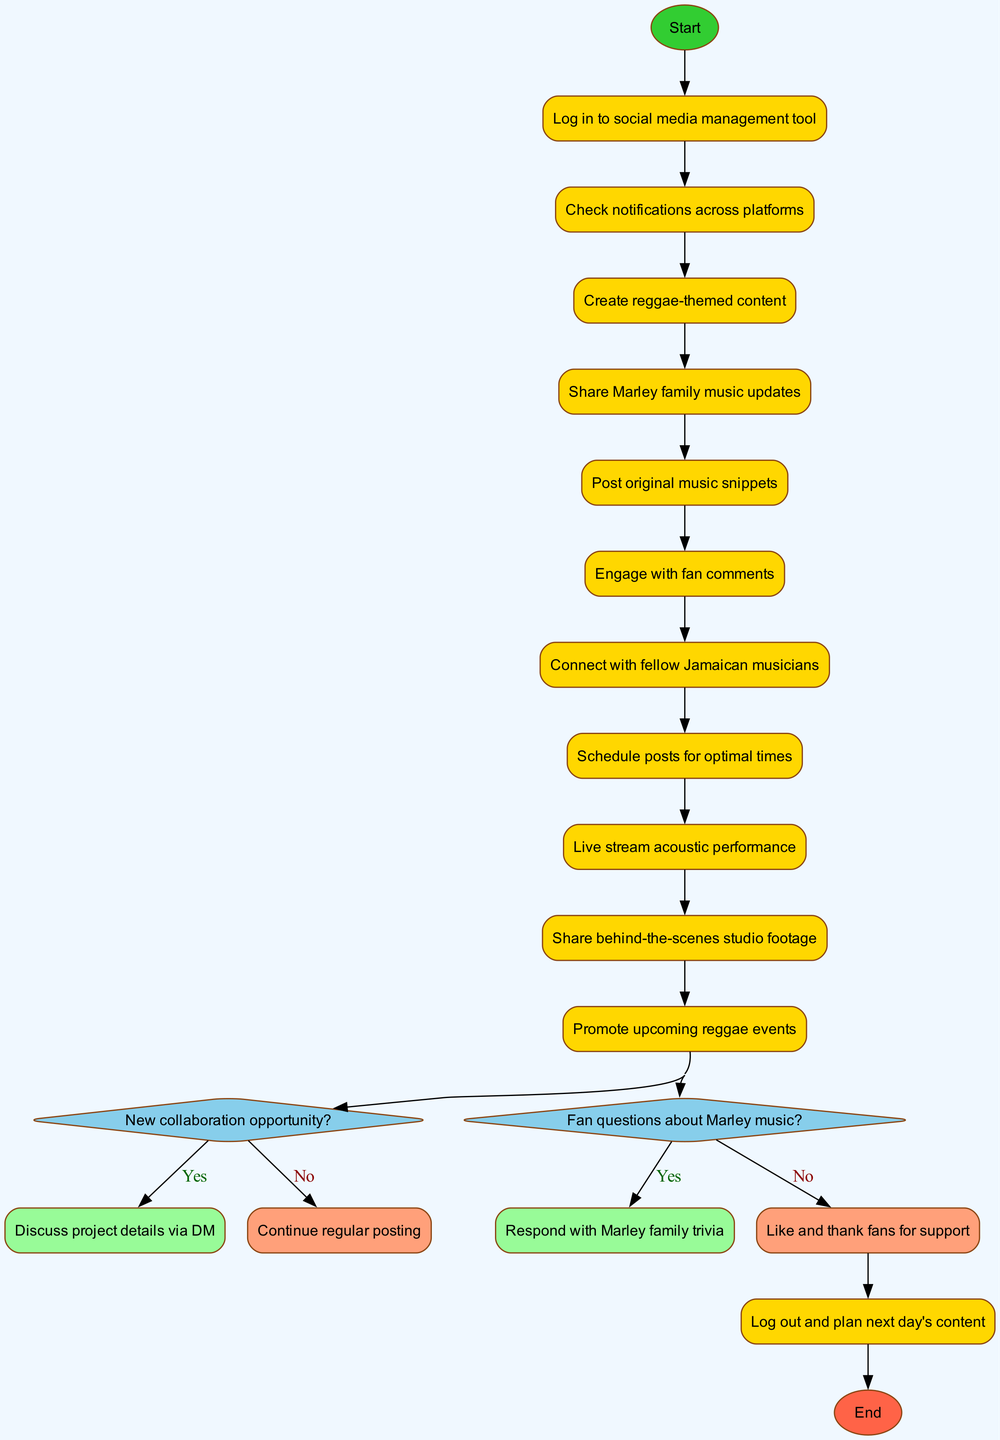What is the first activity in the diagram? The first activity directly connected to the start node is "Check notifications across platforms." It follows immediately after the start node, indicating the first step in the process.
Answer: Check notifications across platforms How many activities are listed in the diagram? To find the number of activities, we count all the activities listed in the data section. There are 10 activities in total.
Answer: 10 What happens if there is a new collaboration opportunity? If there is a new collaboration opportunity, the diagram indicates that the action will lead to "Discuss project details via DM." This is a direct path that branches from the decision node for the collaboration.
Answer: Discuss project details via DM Which activity precedes "Live stream acoustic performance"? The activity "Connect with fellow Jamaican musicians" comes directly before "Live stream acoustic performance" in the sequence of activities shown in the diagram.
Answer: Connect with fellow Jamaican musicians What is the last node in the flow of the diagram? The last node is "Log out and plan next day's content." This is designated as the end node, indicating the conclusion of the activity flow.
Answer: Log out and plan next day's content If there are fan questions about Marley music, what is the next action? If there are fan questions about Marley music, the action specified is to "Respond with Marley family trivia," which follows from the decision point regarding fan questions.
Answer: Respond with Marley family trivia What connects the decision of "Fan questions about Marley music?" to its possible outcomes? The outcomes "Respond with Marley family trivia" and "Like and thank fans for support" are connected to the decision through edges leading from the decision node, indicating the possible branches based on the response.
Answer: Edges leading to the outcomes How many decision nodes are present in the diagram? There are 2 decision nodes in the diagram, as indicated in the data section, each representing a decision point that branches into two possible outcomes.
Answer: 2 What is the activity right before the end node? The activity right before the end node is "Log out and plan next day's content," making it the last action taken before completion of the process in the diagram.
Answer: Log out and plan next day's content 